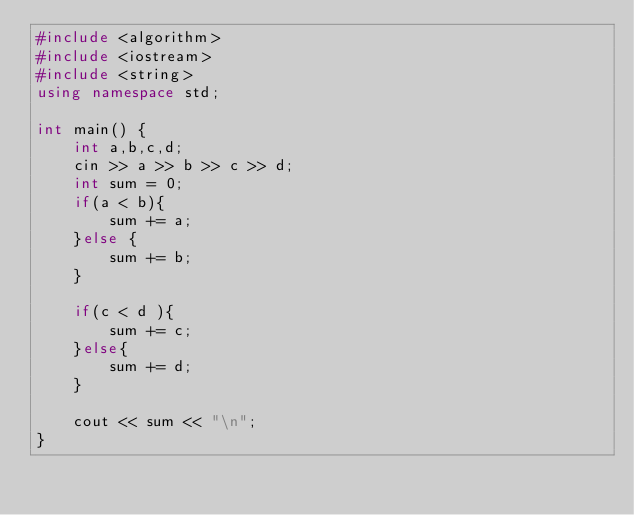Convert code to text. <code><loc_0><loc_0><loc_500><loc_500><_C++_>#include <algorithm>
#include <iostream>
#include <string>
using namespace std;

int main() {
    int a,b,c,d;
    cin >> a >> b >> c >> d;
    int sum = 0;
    if(a < b){
        sum += a;
    }else {
        sum += b;
    }

    if(c < d ){
        sum += c;
    }else{
        sum += d;
    }

    cout << sum << "\n";
}
</code> 